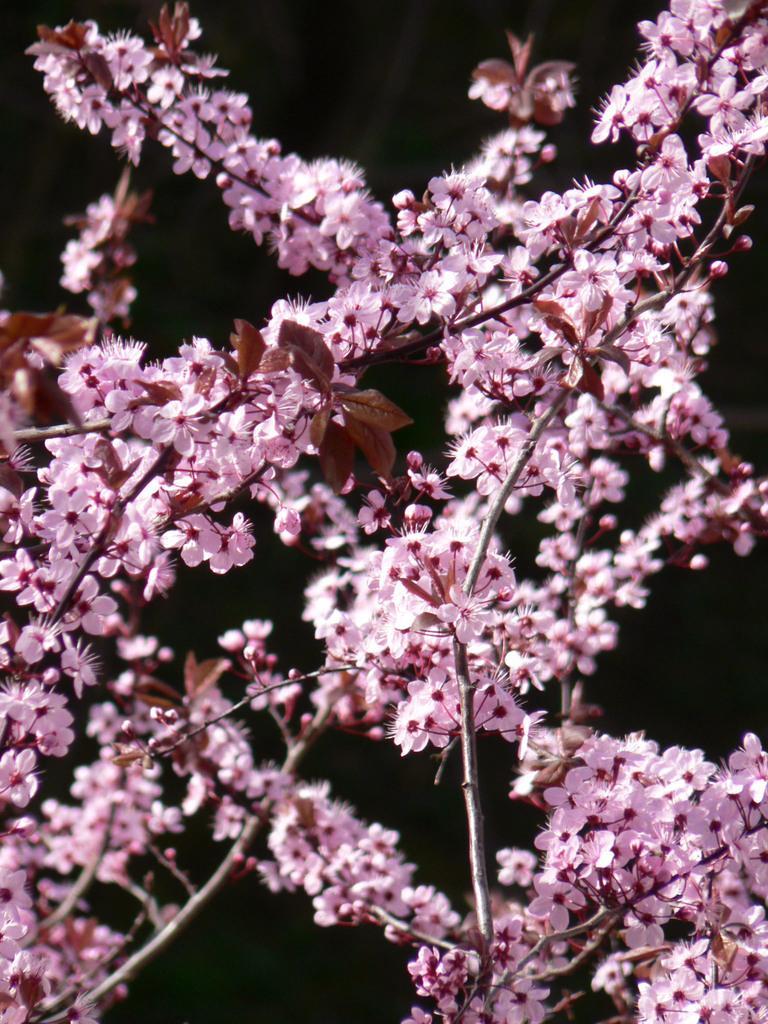Please provide a concise description of this image. In this image, there is a branch of flowers on the black background. 